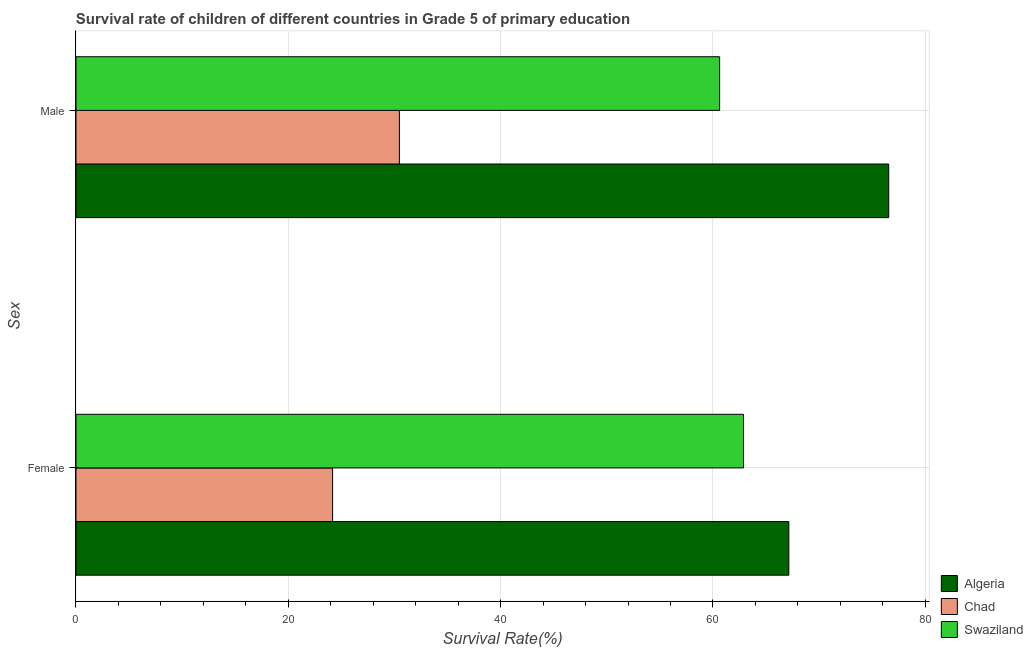How many different coloured bars are there?
Keep it short and to the point. 3. Are the number of bars per tick equal to the number of legend labels?
Your answer should be very brief. Yes. Are the number of bars on each tick of the Y-axis equal?
Your response must be concise. Yes. What is the survival rate of male students in primary education in Chad?
Your answer should be compact. 30.46. Across all countries, what is the maximum survival rate of male students in primary education?
Ensure brevity in your answer.  76.56. Across all countries, what is the minimum survival rate of female students in primary education?
Offer a very short reply. 24.17. In which country was the survival rate of male students in primary education maximum?
Make the answer very short. Algeria. In which country was the survival rate of male students in primary education minimum?
Your answer should be compact. Chad. What is the total survival rate of male students in primary education in the graph?
Your response must be concise. 167.65. What is the difference between the survival rate of male students in primary education in Chad and that in Algeria?
Make the answer very short. -46.1. What is the difference between the survival rate of male students in primary education in Algeria and the survival rate of female students in primary education in Chad?
Provide a short and direct response. 52.38. What is the average survival rate of female students in primary education per country?
Provide a short and direct response. 51.4. What is the difference between the survival rate of male students in primary education and survival rate of female students in primary education in Chad?
Offer a very short reply. 6.29. In how many countries, is the survival rate of male students in primary education greater than 56 %?
Offer a very short reply. 2. What is the ratio of the survival rate of male students in primary education in Chad to that in Swaziland?
Your answer should be very brief. 0.5. Is the survival rate of female students in primary education in Algeria less than that in Swaziland?
Your response must be concise. No. What does the 2nd bar from the top in Male represents?
Give a very brief answer. Chad. What does the 3rd bar from the bottom in Male represents?
Ensure brevity in your answer.  Swaziland. How many bars are there?
Make the answer very short. 6. Are all the bars in the graph horizontal?
Make the answer very short. Yes. How many countries are there in the graph?
Give a very brief answer. 3. What is the difference between two consecutive major ticks on the X-axis?
Your answer should be very brief. 20. Does the graph contain grids?
Provide a succinct answer. Yes. How many legend labels are there?
Offer a very short reply. 3. How are the legend labels stacked?
Your answer should be compact. Vertical. What is the title of the graph?
Offer a very short reply. Survival rate of children of different countries in Grade 5 of primary education. Does "Small states" appear as one of the legend labels in the graph?
Give a very brief answer. No. What is the label or title of the X-axis?
Give a very brief answer. Survival Rate(%). What is the label or title of the Y-axis?
Make the answer very short. Sex. What is the Survival Rate(%) in Algeria in Female?
Make the answer very short. 67.15. What is the Survival Rate(%) of Chad in Female?
Offer a terse response. 24.17. What is the Survival Rate(%) in Swaziland in Female?
Your answer should be very brief. 62.88. What is the Survival Rate(%) in Algeria in Male?
Ensure brevity in your answer.  76.56. What is the Survival Rate(%) of Chad in Male?
Give a very brief answer. 30.46. What is the Survival Rate(%) of Swaziland in Male?
Give a very brief answer. 60.63. Across all Sex, what is the maximum Survival Rate(%) of Algeria?
Offer a very short reply. 76.56. Across all Sex, what is the maximum Survival Rate(%) in Chad?
Make the answer very short. 30.46. Across all Sex, what is the maximum Survival Rate(%) of Swaziland?
Your answer should be very brief. 62.88. Across all Sex, what is the minimum Survival Rate(%) in Algeria?
Your answer should be very brief. 67.15. Across all Sex, what is the minimum Survival Rate(%) of Chad?
Provide a short and direct response. 24.17. Across all Sex, what is the minimum Survival Rate(%) of Swaziland?
Give a very brief answer. 60.63. What is the total Survival Rate(%) in Algeria in the graph?
Give a very brief answer. 143.71. What is the total Survival Rate(%) in Chad in the graph?
Keep it short and to the point. 54.64. What is the total Survival Rate(%) of Swaziland in the graph?
Provide a short and direct response. 123.52. What is the difference between the Survival Rate(%) in Algeria in Female and that in Male?
Provide a short and direct response. -9.41. What is the difference between the Survival Rate(%) in Chad in Female and that in Male?
Offer a very short reply. -6.29. What is the difference between the Survival Rate(%) in Swaziland in Female and that in Male?
Ensure brevity in your answer.  2.25. What is the difference between the Survival Rate(%) of Algeria in Female and the Survival Rate(%) of Chad in Male?
Provide a short and direct response. 36.69. What is the difference between the Survival Rate(%) in Algeria in Female and the Survival Rate(%) in Swaziland in Male?
Your answer should be very brief. 6.52. What is the difference between the Survival Rate(%) in Chad in Female and the Survival Rate(%) in Swaziland in Male?
Offer a very short reply. -36.46. What is the average Survival Rate(%) in Algeria per Sex?
Make the answer very short. 71.85. What is the average Survival Rate(%) of Chad per Sex?
Your answer should be very brief. 27.32. What is the average Survival Rate(%) of Swaziland per Sex?
Offer a terse response. 61.76. What is the difference between the Survival Rate(%) in Algeria and Survival Rate(%) in Chad in Female?
Give a very brief answer. 42.98. What is the difference between the Survival Rate(%) of Algeria and Survival Rate(%) of Swaziland in Female?
Keep it short and to the point. 4.27. What is the difference between the Survival Rate(%) in Chad and Survival Rate(%) in Swaziland in Female?
Keep it short and to the point. -38.71. What is the difference between the Survival Rate(%) in Algeria and Survival Rate(%) in Chad in Male?
Your response must be concise. 46.1. What is the difference between the Survival Rate(%) of Algeria and Survival Rate(%) of Swaziland in Male?
Keep it short and to the point. 15.93. What is the difference between the Survival Rate(%) in Chad and Survival Rate(%) in Swaziland in Male?
Keep it short and to the point. -30.17. What is the ratio of the Survival Rate(%) of Algeria in Female to that in Male?
Offer a very short reply. 0.88. What is the ratio of the Survival Rate(%) in Chad in Female to that in Male?
Make the answer very short. 0.79. What is the ratio of the Survival Rate(%) of Swaziland in Female to that in Male?
Offer a very short reply. 1.04. What is the difference between the highest and the second highest Survival Rate(%) in Algeria?
Provide a succinct answer. 9.41. What is the difference between the highest and the second highest Survival Rate(%) in Chad?
Your answer should be compact. 6.29. What is the difference between the highest and the second highest Survival Rate(%) in Swaziland?
Your answer should be very brief. 2.25. What is the difference between the highest and the lowest Survival Rate(%) in Algeria?
Your answer should be compact. 9.41. What is the difference between the highest and the lowest Survival Rate(%) in Chad?
Your response must be concise. 6.29. What is the difference between the highest and the lowest Survival Rate(%) of Swaziland?
Provide a short and direct response. 2.25. 